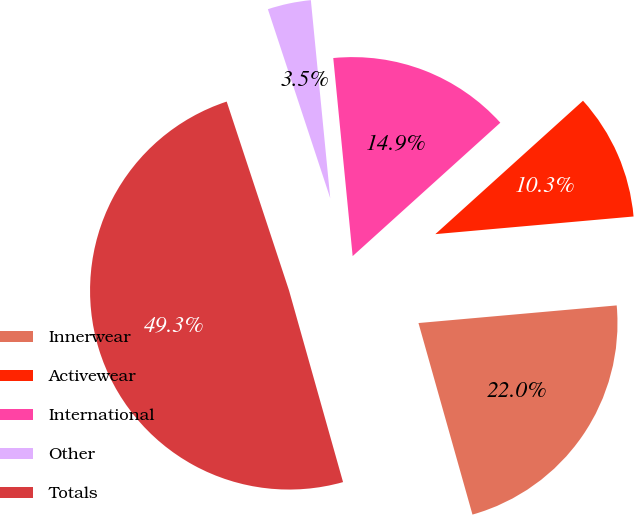<chart> <loc_0><loc_0><loc_500><loc_500><pie_chart><fcel>Innerwear<fcel>Activewear<fcel>International<fcel>Other<fcel>Totals<nl><fcel>22.04%<fcel>10.28%<fcel>14.86%<fcel>3.52%<fcel>49.3%<nl></chart> 